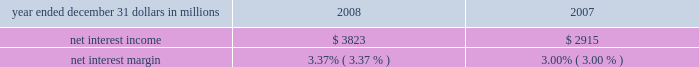Consolidated income statement review our consolidated income statement is presented in item 8 of this report .
Net income for 2008 was $ 882 million and for 2007 was $ 1.467 billion .
Total revenue for 2008 increased 7% ( 7 % ) compared with 2007 .
We created positive operating leverage in the year-to-date comparison as total noninterest expense increased 3% ( 3 % ) in the comparison .
Net interest income and net interest margin year ended december 31 dollars in millions 2008 2007 .
Changes in net interest income and margin result from the interaction of the volume and composition of interest-earning assets and related yields , interest-bearing liabilities and related rates paid , and noninterest-bearing sources of funding .
See statistical information 2013 analysis of year-to-year changes in net interest ( unaudited ) income and average consolidated balance sheet and net interest analysis in item 8 of this report for additional information .
The 31% ( 31 % ) increase in net interest income for 2008 compared with 2007 was favorably impacted by the $ 16.5 billion , or 17% ( 17 % ) , increase in average interest-earning assets and a decrease in funding costs .
The 2008 net interest margin was positively affected by declining rates paid on deposits and borrowings compared with the prior year .
The reasons driving the higher interest-earning assets in these comparisons are further discussed in the balance sheet highlights portion of the executive summary section of this item 7 .
The net interest margin was 3.37% ( 3.37 % ) for 2008 and 3.00% ( 3.00 % ) for 2007 .
The following factors impacted the comparison : 2022 a decrease in the rate paid on interest-bearing liabilities of 140 basis points .
The rate paid on interest-bearing deposits , the single largest component , decreased 123 basis points .
2022 these factors were partially offset by a 77 basis point decrease in the yield on interest-earning assets .
The yield on loans , the single largest component , decreased 109 basis points .
2022 in addition , the impact of noninterest-bearing sources of funding decreased 26 basis points due to lower interest rates and a lower proportion of noninterest- bearing sources of funding to interest-earning assets .
For comparing to the broader market , during 2008 the average federal funds rate was 1.94% ( 1.94 % ) compared with 5.03% ( 5.03 % ) for 2007 .
We expect our full-year 2009 net interest income to benefit from the impact of interest accretion of discounts resulting from purchase accounting marks and deposit pricing alignment related to our national city acquisition .
We also currently expect our 2009 net interest margin to improve on a year-over-year basis .
Noninterest income summary noninterest income was $ 3.367 billion for 2008 and $ 3.790 billion for 2007 .
Noninterest income for 2008 included the following : 2022 gains of $ 246 million related to the mark-to-market adjustment on our blackrock ltip shares obligation , 2022 losses related to our commercial mortgage loans held for sale of $ 197 million , net of hedges , 2022 impairment and other losses related to alternative investments of $ 179 million , 2022 income from hilliard lyons totaling $ 164 million , including the first quarter gain of $ 114 million from the sale of this business , 2022 net securities losses of $ 206 million , 2022 a first quarter gain of $ 95 million related to the redemption of a portion of our visa class b common shares related to visa 2019s march 2008 initial public offering , 2022 a third quarter $ 61 million reversal of a legal contingency reserve established in connection with an acquisition due to a settlement , 2022 trading losses of $ 55 million , 2022 a $ 35 million impairment charge on commercial mortgage servicing rights , and 2022 equity management losses of $ 24 million .
Noninterest income for 2007 included the following : 2022 the impact of $ 82 million gain recognized in connection with our transfer of blackrock shares to satisfy a portion of pnc 2019s ltip obligation and a $ 209 million net loss on our ltip shares obligation , 2022 income from hilliard lyons totaling $ 227 million , 2022 trading income of $ 104 million , 2022 equity management gains of $ 102 million , and 2022 gains related to our commercial mortgage loans held for sale of $ 3 million , net of hedges .
Apart from the impact of these items , noninterest income increased $ 16 million in 2008 compared with 2007 .
Additional analysis fund servicing fees increased $ 69 million in 2008 , to $ 904 million , compared with $ 835 million in 2007 .
The impact of the december 2007 acquisition of albridge solutions inc .
( 201calbridge solutions 201d ) and growth in global investment servicing 2019s offshore operations were the primary drivers of this increase .
Global investment servicing provided fund accounting/ administration services for $ 839 billion of net fund investment assets and provided custody services for $ 379 billion of fund .
What was the average net interest margin for 2008 and for 2007? 
Computations: ((3.37 + 3.00) / 2)
Answer: 3.185. 